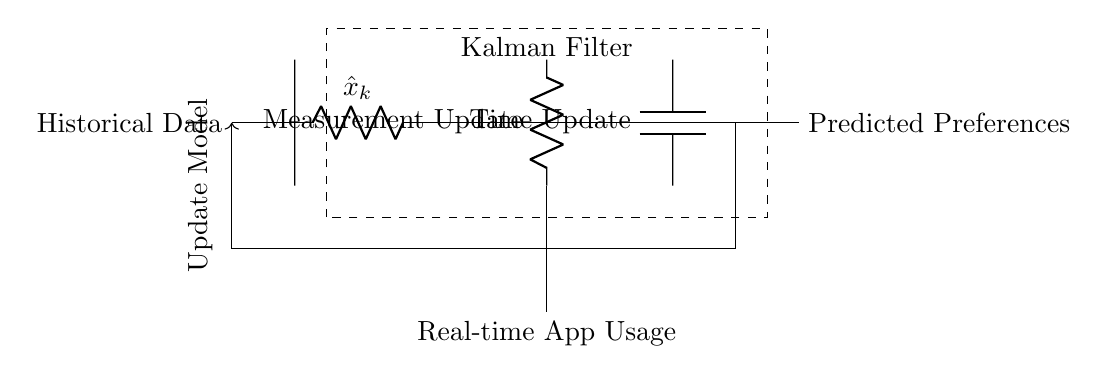What does the dashed box represent? The dashed box encloses the Kalman Filter component, indicating its function as a processing element for the circuit.
Answer: Kalman Filter What is the input to the Kalman Filter? The input is Historical Data, which is shown on the left side of the diagram leading into the Kalman Filter.
Answer: Historical Data What occurs at the Measurement Update stage? The Measurement Update stage processes the current measurements to refine the estimates produced by the Kalman Filter before making predictions.
Answer: Measurement Update What is the output of the circuit? The output is the Predicted Preferences, which are derived from the processing of historical data through the Kalman Filter.
Answer: Predicted Preferences Which component is used for the Time Update? The Time Update is represented by a capacitor, indicating it plays a role in changing the state of the filter over time.
Answer: Capacitor How does the circuit feedback to the model? There is a feedback loop indicated by an arrow, connecting the Predicted Preferences back to the Historical Data, suggesting the process of updating the model with new data.
Answer: Update Model What type of analysis does this circuit perform? The circuit performs real-time prediction of user preferences based on the historical usage data, reflecting the Kalman Filter's role in filtering and estimating states.
Answer: Real-time prediction 